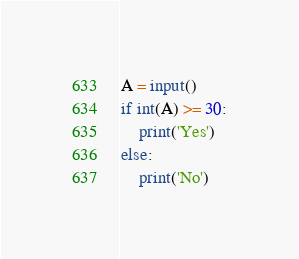<code> <loc_0><loc_0><loc_500><loc_500><_Python_>A = input()
if int(A) >= 30:
    print('Yes')
else:
    print('No')</code> 